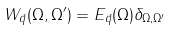Convert formula to latex. <formula><loc_0><loc_0><loc_500><loc_500>W _ { \vec { q } } ( \Omega , \Omega ^ { \prime } ) = E _ { \vec { q } } ( \Omega ) \delta _ { \Omega , \Omega ^ { \prime } }</formula> 